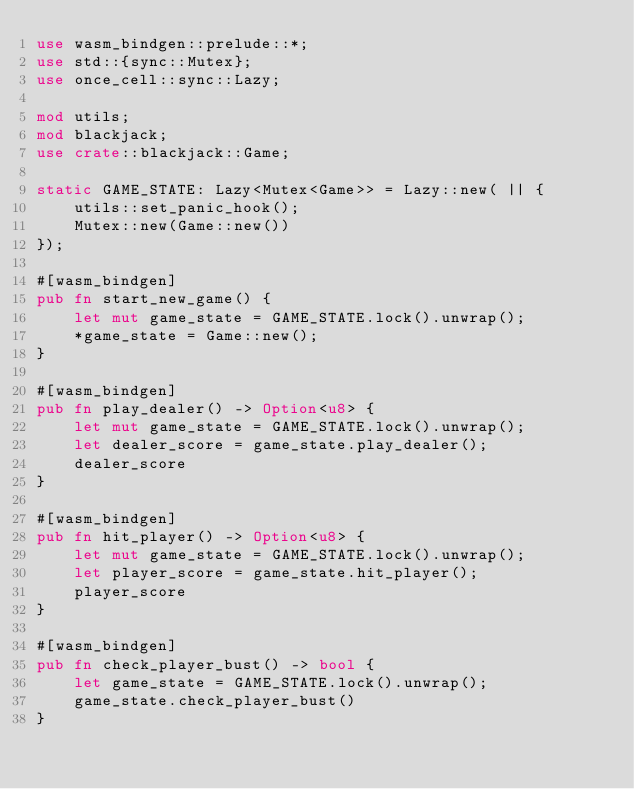<code> <loc_0><loc_0><loc_500><loc_500><_Rust_>use wasm_bindgen::prelude::*;
use std::{sync::Mutex};
use once_cell::sync::Lazy;

mod utils;
mod blackjack;
use crate::blackjack::Game;

static GAME_STATE: Lazy<Mutex<Game>> = Lazy::new( || {
    utils::set_panic_hook();
    Mutex::new(Game::new())
});

#[wasm_bindgen]
pub fn start_new_game() {
    let mut game_state = GAME_STATE.lock().unwrap();
    *game_state = Game::new();
}

#[wasm_bindgen]
pub fn play_dealer() -> Option<u8> {
    let mut game_state = GAME_STATE.lock().unwrap();
    let dealer_score = game_state.play_dealer();
    dealer_score
}

#[wasm_bindgen]
pub fn hit_player() -> Option<u8> {
    let mut game_state = GAME_STATE.lock().unwrap();
    let player_score = game_state.hit_player();
    player_score
}

#[wasm_bindgen]
pub fn check_player_bust() -> bool {
    let game_state = GAME_STATE.lock().unwrap();
    game_state.check_player_bust()
}
</code> 